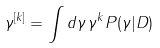<formula> <loc_0><loc_0><loc_500><loc_500>\gamma ^ { [ k ] } = \int d \gamma \, \gamma ^ { k } P ( \gamma | D )</formula> 